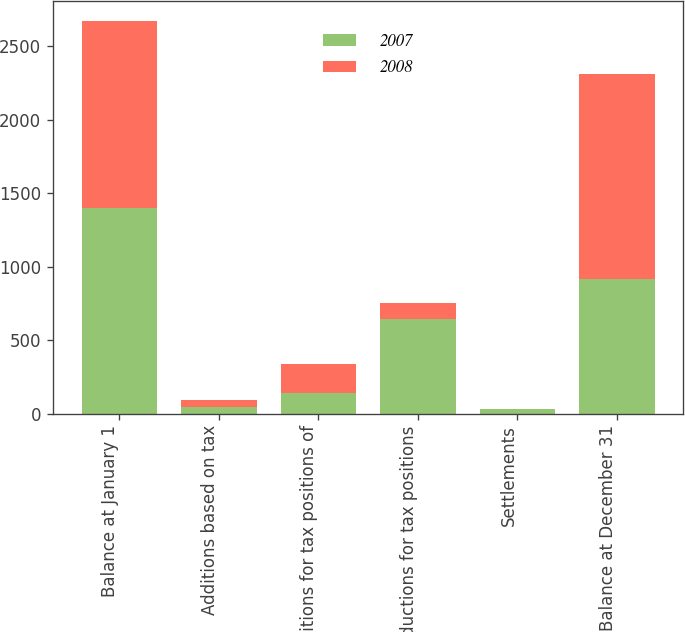Convert chart to OTSL. <chart><loc_0><loc_0><loc_500><loc_500><stacked_bar_chart><ecel><fcel>Balance at January 1<fcel>Additions based on tax<fcel>Additions for tax positions of<fcel>Reductions for tax positions<fcel>Settlements<fcel>Balance at December 31<nl><fcel>2007<fcel>1400<fcel>46<fcel>141<fcel>642<fcel>31<fcel>914<nl><fcel>2008<fcel>1274<fcel>46<fcel>197<fcel>114<fcel>3<fcel>1400<nl></chart> 